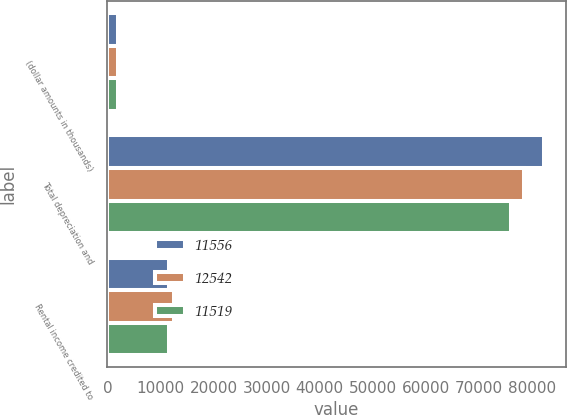Convert chart. <chart><loc_0><loc_0><loc_500><loc_500><stacked_bar_chart><ecel><fcel>(dollar amounts in thousands)<fcel>Total depreciation and<fcel>Rental income credited to<nl><fcel>11556<fcel>2014<fcel>82296<fcel>11556<nl><fcel>12542<fcel>2013<fcel>78601<fcel>12542<nl><fcel>11519<fcel>2012<fcel>76170<fcel>11519<nl></chart> 